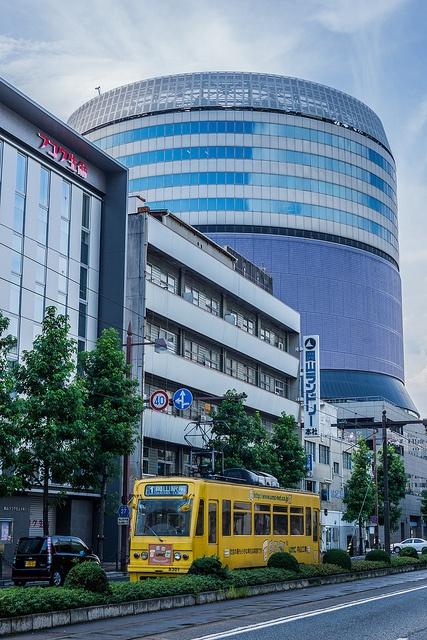Describe the objects in this image and their specific colors. I can see bus in lightblue, olive, and black tones, car in lightblue, black, navy, and blue tones, and car in lightblue, lavender, black, and gray tones in this image. 